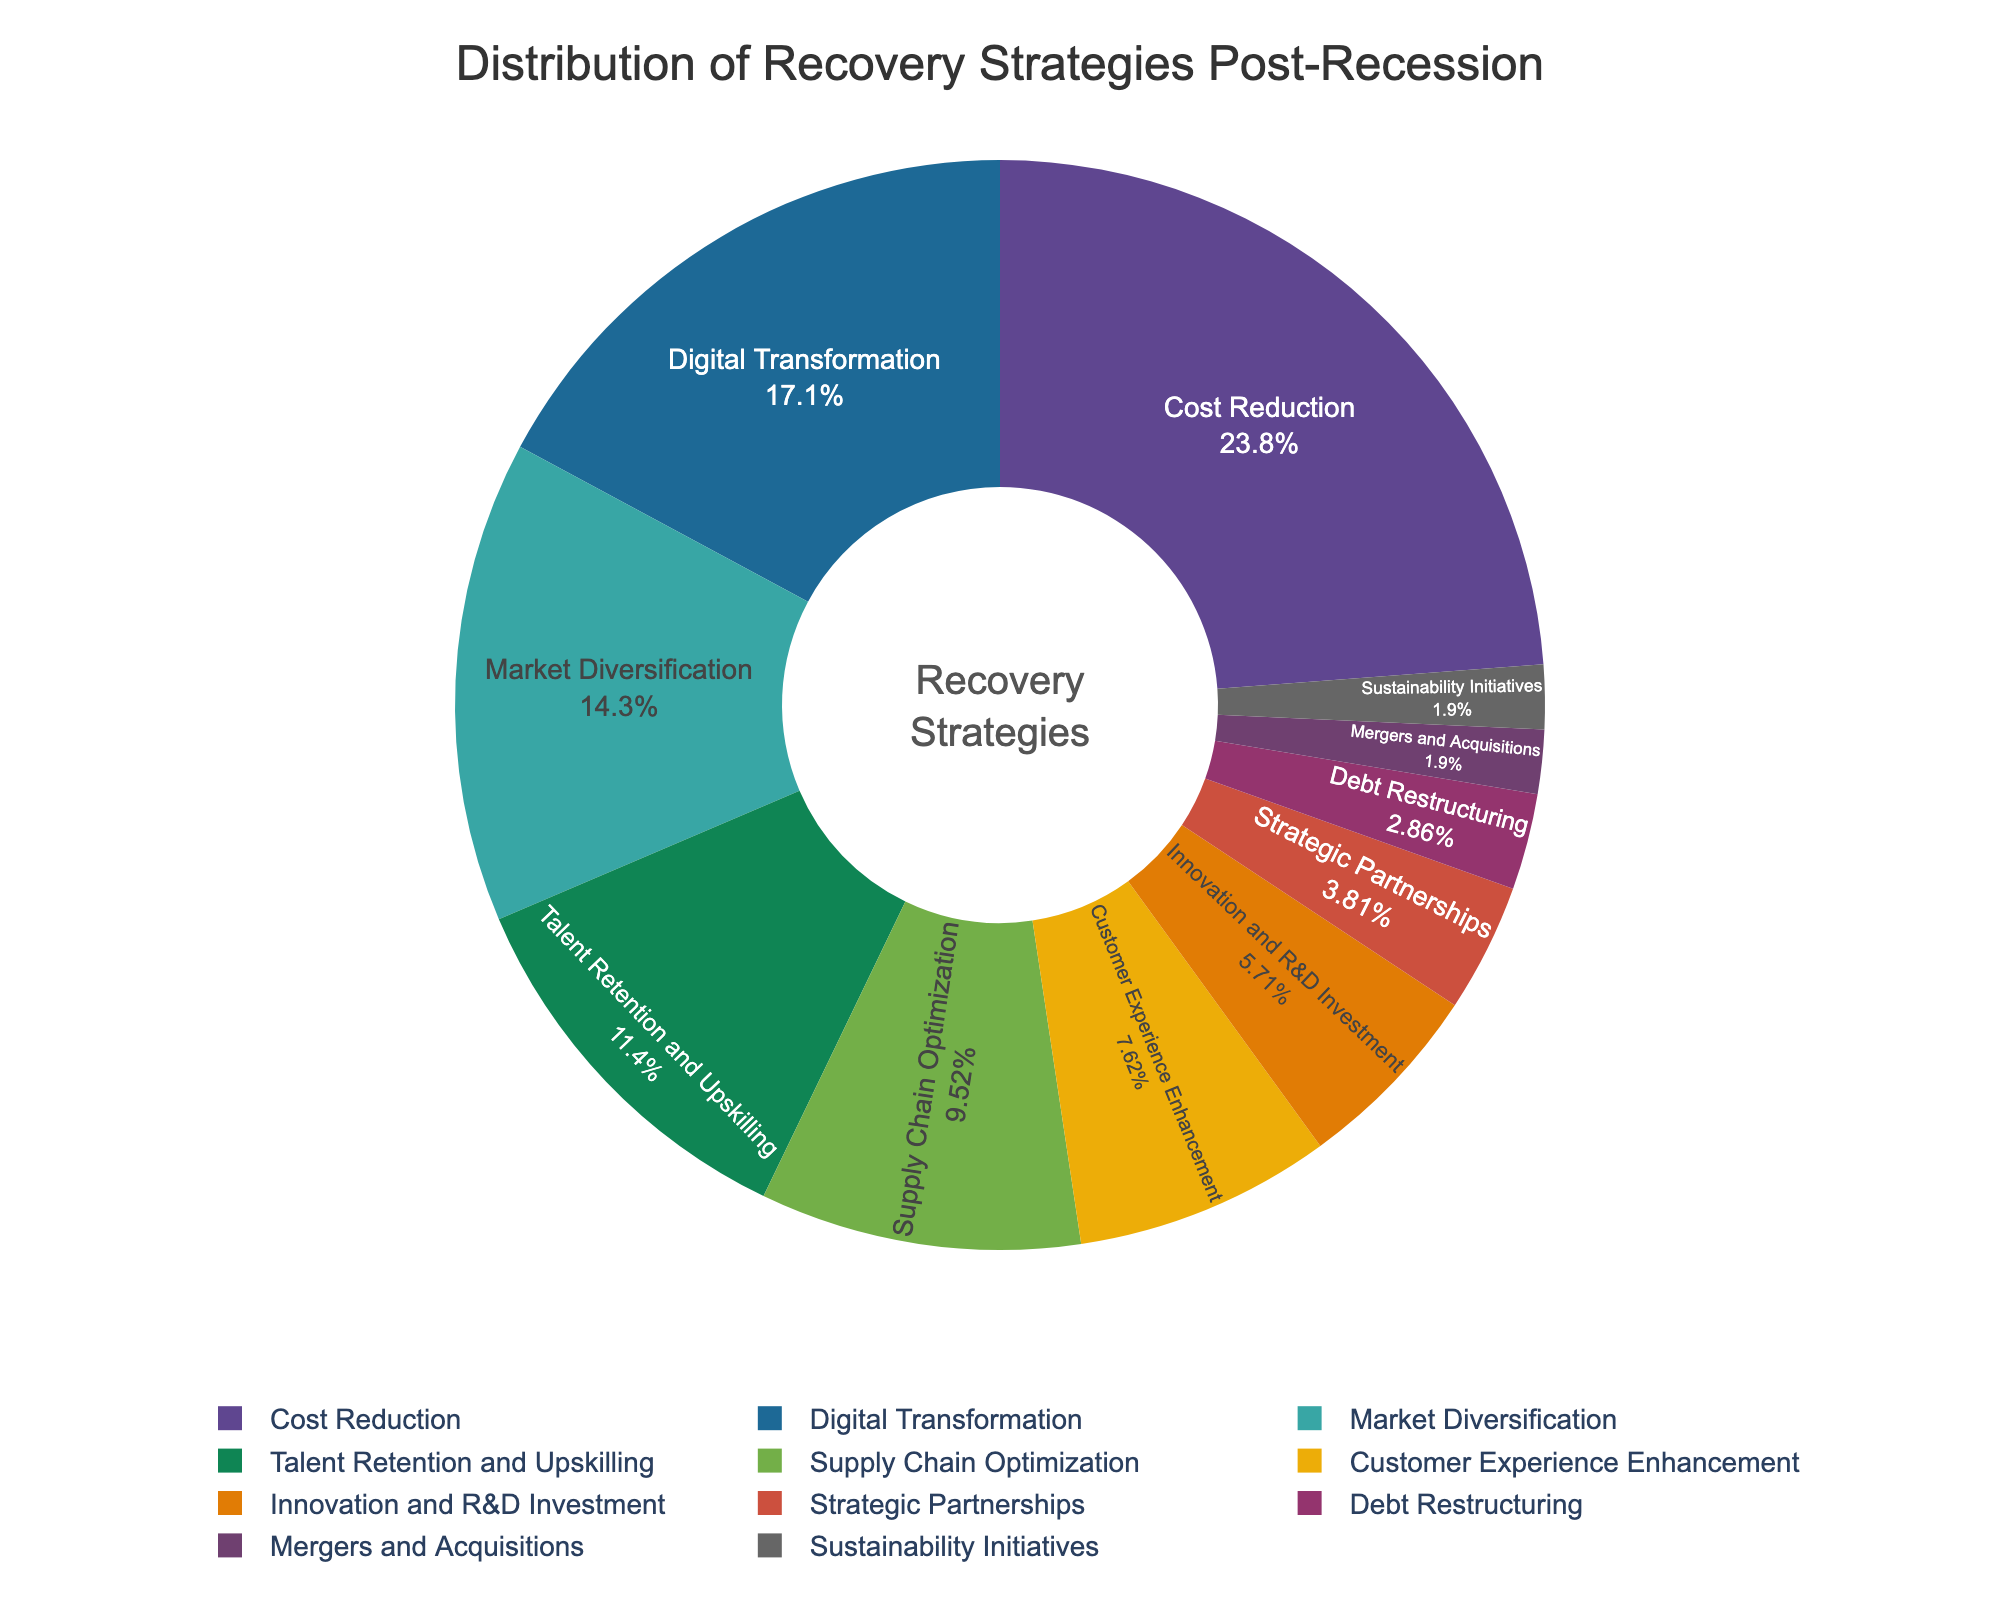What is the most implemented recovery strategy post-recession? The pie chart shows various recovery strategies, and the one with the largest slice represents the most implemented strategy. Here, "Cost Reduction" has the largest slice.
Answer: Cost Reduction Which strategy has a higher percentage: Talent Retention and Upskilling or Supply Chain Optimization? By comparing the sizes of the slices for "Talent Retention and Upskilling" (12%) and "Supply Chain Optimization" (10%), it's evident that "Talent Retention and Upskilling" has a higher percentage.
Answer: Talent Retention and Upskilling What is the combined percentage of Digital Transformation and Customer Experience Enhancement? Summing up the percentages of "Digital Transformation" (18%) and "Customer Experience Enhancement" (8%) gives 18% + 8% = 26%.
Answer: 26% Are there any recovery strategies implemented by less than 5% of businesses? If so, which ones? By identifying slices with less than 5%, "Strategic Partnerships" (4%), "Debt Restructuring" (3%), "Mergers and Acquisitions" (2%), and "Sustainability Initiatives" (2%) meet this criterion.
Answer: Strategic Partnerships, Debt Restructuring, Mergers and Acquisitions, Sustainability Initiatives Which two strategies together account for the largest percentage of implementations? Identifying and summing the top two largest slices: "Cost Reduction" (25%) and "Digital Transformation" (18%), combined result in 25% + 18% = 43%, the highest combination.
Answer: Cost Reduction and Digital Transformation What is the difference in percentage between Market Diversification and Innovation and R&D Investment? Subtracting the percentage of "Innovation and R&D Investment" (6%) from "Market Diversification" (15%) gives 15% - 6% = 9%.
Answer: 9% Which slice of the pie chart is the smallest, and what is its percentage? The smallest slice represents "Mergers and Acquisitions" and "Sustainability Initiatives," both at 2%.
Answer: Mergers and Acquisitions and Sustainability Initiatives, 2% How does the percentage of Supply Chain Optimization compare to Customer Experience Enhancement? Comparing their percentages: "Supply Chain Optimization" (10%) is larger than "Customer Experience Enhancement" (8%).
Answer: Supply Chain Optimization is larger 